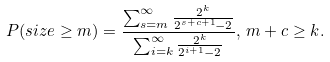Convert formula to latex. <formula><loc_0><loc_0><loc_500><loc_500>P ( s i z e \geq m ) = \frac { \sum _ { s = m } ^ { \infty } \frac { 2 ^ { k } } { 2 ^ { s + c + 1 } - 2 } } { \sum _ { i = k } ^ { \infty } \frac { 2 ^ { k } } { 2 ^ { i + 1 } - 2 } } , \, m + c \geq k .</formula> 